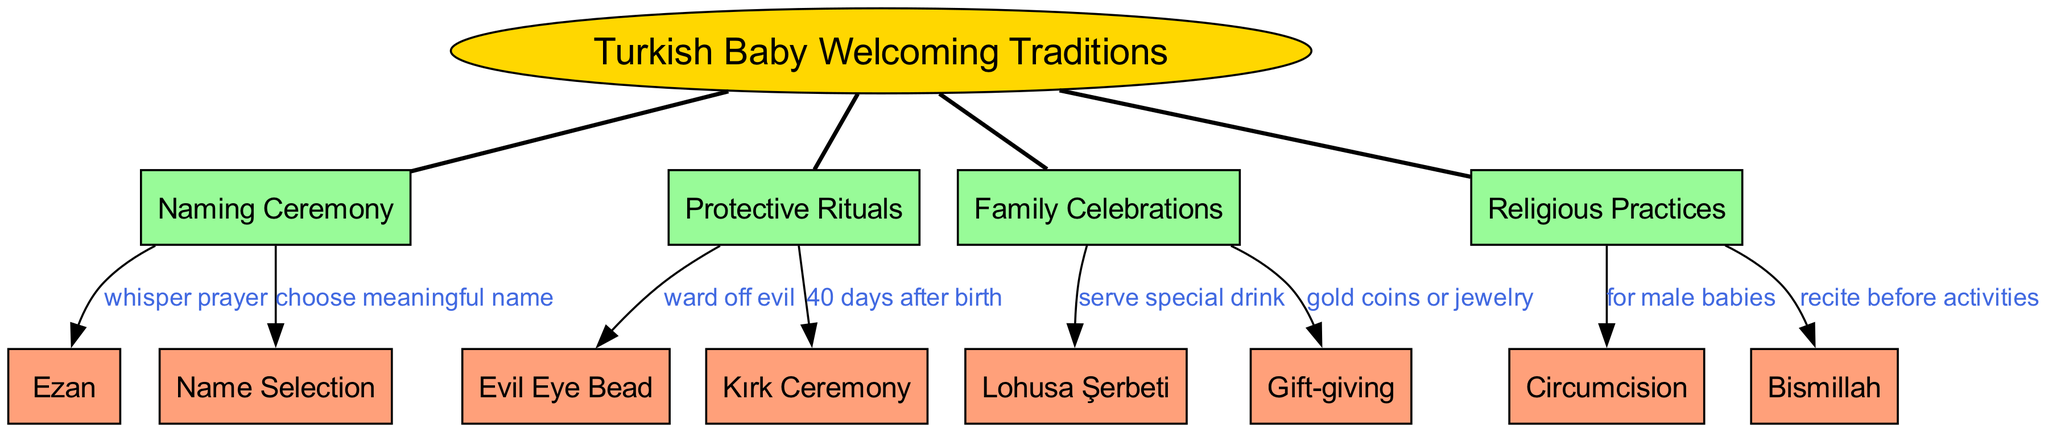What is the central concept of the diagram? The diagram's central concept is clearly labeled at the center as "Turkish Baby Welcoming Traditions." This is easily identified, as it's represented in an oval shape, distinguishing it from other elements.
Answer: Turkish Baby Welcoming Traditions How many main elements are in the diagram? The diagram includes four main elements: Naming Ceremony, Protective Rituals, Family Celebrations, and Religious Practices. By counting these distinct nodes radiating from the central concept, we can determine their total.
Answer: 4 What is whispered during the Naming Ceremony? The connection from the "Naming Ceremony" node to the "Ezan" node indicates that a prayer, specifically the "Ezan," is whispered during this ceremony. This relationship helps identify the particular prayer connected to naming.
Answer: Ezan What is served during Family Celebrations? The connection from "Family Celebrations" to "Lohusa Şerbeti" reveals that a special drink named "Lohusa Şerbeti" is served as part of these celebrations. This direct relationship identifies the specific item associated with family festivities.
Answer: Lohusa Şerbeti What is the purpose of the Evil Eye Bead? The link from "Protective Rituals" to the "Evil Eye Bead" states that it is used to "ward off evil." This clarity in the connection helps understand the protective significance associated with this item in Turkish culture.
Answer: ward off evil What are the two religious practices associated with welcoming a new baby? In the "Religious Practices" section of the diagram, two distinct practices are highlighted: "Circumcision" and "Bismillah." By examining the nodes within this category, we discern the important religious customs related to newborns.
Answer: Circumcision, Bismillah How many connections are related to Naming Ceremony? The "Naming Ceremony" has two connections: one to "Ezan" and the other to "Name Selection". By examining the number of edges emerging from this node, we can easily count the connections it has.
Answer: 2 What is the significance of Kırk Ceremony? The connection from "Protective Rituals" to "Kırk Ceremony" notes that it occurs "40 days after birth." This relationship emphasizes the timeframe and cultural context of this specific ritual related to welcoming a new baby.
Answer: 40 days after birth What is a common gift during Family Celebrations? The connection from "Family Celebrations" to "Gift-giving" indicates that gold coins or jewelry are commonly given. This relationship helps identify the traditional gifts associated with celebrating a new birth.
Answer: gold coins or jewelry 